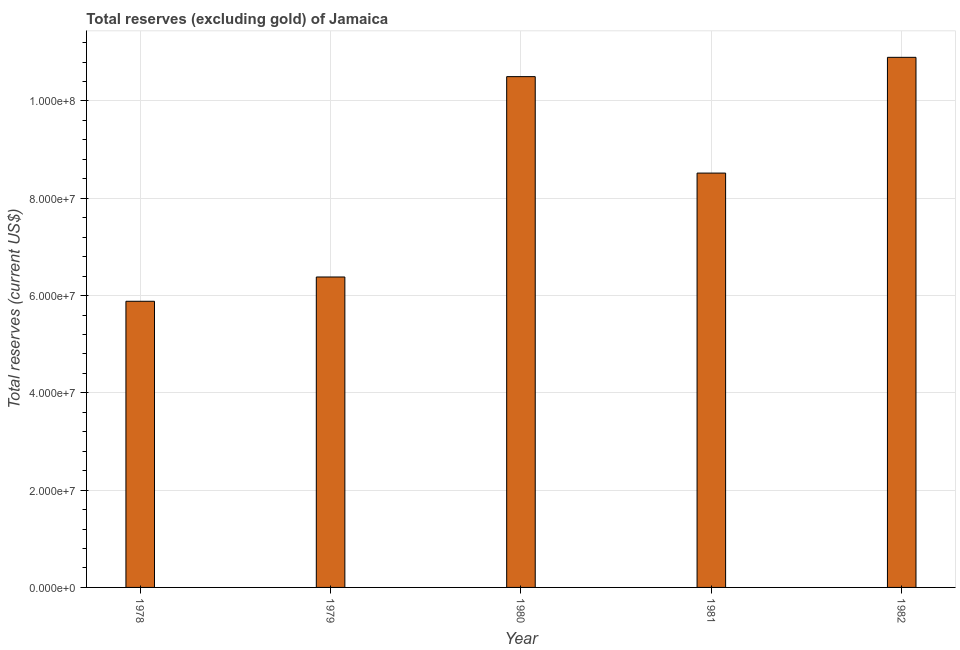Does the graph contain grids?
Your response must be concise. Yes. What is the title of the graph?
Your answer should be compact. Total reserves (excluding gold) of Jamaica. What is the label or title of the Y-axis?
Your answer should be very brief. Total reserves (current US$). What is the total reserves (excluding gold) in 1982?
Your answer should be very brief. 1.09e+08. Across all years, what is the maximum total reserves (excluding gold)?
Provide a succinct answer. 1.09e+08. Across all years, what is the minimum total reserves (excluding gold)?
Offer a terse response. 5.88e+07. In which year was the total reserves (excluding gold) maximum?
Provide a succinct answer. 1982. In which year was the total reserves (excluding gold) minimum?
Provide a succinct answer. 1978. What is the sum of the total reserves (excluding gold)?
Offer a very short reply. 4.22e+08. What is the difference between the total reserves (excluding gold) in 1980 and 1981?
Ensure brevity in your answer.  1.98e+07. What is the average total reserves (excluding gold) per year?
Provide a succinct answer. 8.44e+07. What is the median total reserves (excluding gold)?
Give a very brief answer. 8.52e+07. What is the ratio of the total reserves (excluding gold) in 1978 to that in 1979?
Your answer should be compact. 0.92. Is the total reserves (excluding gold) in 1978 less than that in 1979?
Your answer should be compact. Yes. Is the difference between the total reserves (excluding gold) in 1980 and 1981 greater than the difference between any two years?
Make the answer very short. No. What is the difference between the highest and the second highest total reserves (excluding gold)?
Make the answer very short. 3.97e+06. Is the sum of the total reserves (excluding gold) in 1981 and 1982 greater than the maximum total reserves (excluding gold) across all years?
Make the answer very short. Yes. What is the difference between the highest and the lowest total reserves (excluding gold)?
Give a very brief answer. 5.01e+07. In how many years, is the total reserves (excluding gold) greater than the average total reserves (excluding gold) taken over all years?
Offer a terse response. 3. How many bars are there?
Offer a terse response. 5. How many years are there in the graph?
Your response must be concise. 5. Are the values on the major ticks of Y-axis written in scientific E-notation?
Give a very brief answer. Yes. What is the Total reserves (current US$) in 1978?
Offer a terse response. 5.88e+07. What is the Total reserves (current US$) in 1979?
Keep it short and to the point. 6.38e+07. What is the Total reserves (current US$) in 1980?
Ensure brevity in your answer.  1.05e+08. What is the Total reserves (current US$) of 1981?
Ensure brevity in your answer.  8.52e+07. What is the Total reserves (current US$) of 1982?
Provide a short and direct response. 1.09e+08. What is the difference between the Total reserves (current US$) in 1978 and 1979?
Ensure brevity in your answer.  -4.99e+06. What is the difference between the Total reserves (current US$) in 1978 and 1980?
Your response must be concise. -4.62e+07. What is the difference between the Total reserves (current US$) in 1978 and 1981?
Keep it short and to the point. -2.64e+07. What is the difference between the Total reserves (current US$) in 1978 and 1982?
Give a very brief answer. -5.01e+07. What is the difference between the Total reserves (current US$) in 1979 and 1980?
Ensure brevity in your answer.  -4.12e+07. What is the difference between the Total reserves (current US$) in 1979 and 1981?
Give a very brief answer. -2.14e+07. What is the difference between the Total reserves (current US$) in 1979 and 1982?
Ensure brevity in your answer.  -4.52e+07. What is the difference between the Total reserves (current US$) in 1980 and 1981?
Offer a terse response. 1.98e+07. What is the difference between the Total reserves (current US$) in 1980 and 1982?
Your answer should be very brief. -3.97e+06. What is the difference between the Total reserves (current US$) in 1981 and 1982?
Offer a very short reply. -2.38e+07. What is the ratio of the Total reserves (current US$) in 1978 to that in 1979?
Make the answer very short. 0.92. What is the ratio of the Total reserves (current US$) in 1978 to that in 1980?
Make the answer very short. 0.56. What is the ratio of the Total reserves (current US$) in 1978 to that in 1981?
Offer a terse response. 0.69. What is the ratio of the Total reserves (current US$) in 1978 to that in 1982?
Offer a very short reply. 0.54. What is the ratio of the Total reserves (current US$) in 1979 to that in 1980?
Give a very brief answer. 0.61. What is the ratio of the Total reserves (current US$) in 1979 to that in 1981?
Keep it short and to the point. 0.75. What is the ratio of the Total reserves (current US$) in 1979 to that in 1982?
Your answer should be very brief. 0.59. What is the ratio of the Total reserves (current US$) in 1980 to that in 1981?
Offer a terse response. 1.23. What is the ratio of the Total reserves (current US$) in 1980 to that in 1982?
Keep it short and to the point. 0.96. What is the ratio of the Total reserves (current US$) in 1981 to that in 1982?
Make the answer very short. 0.78. 